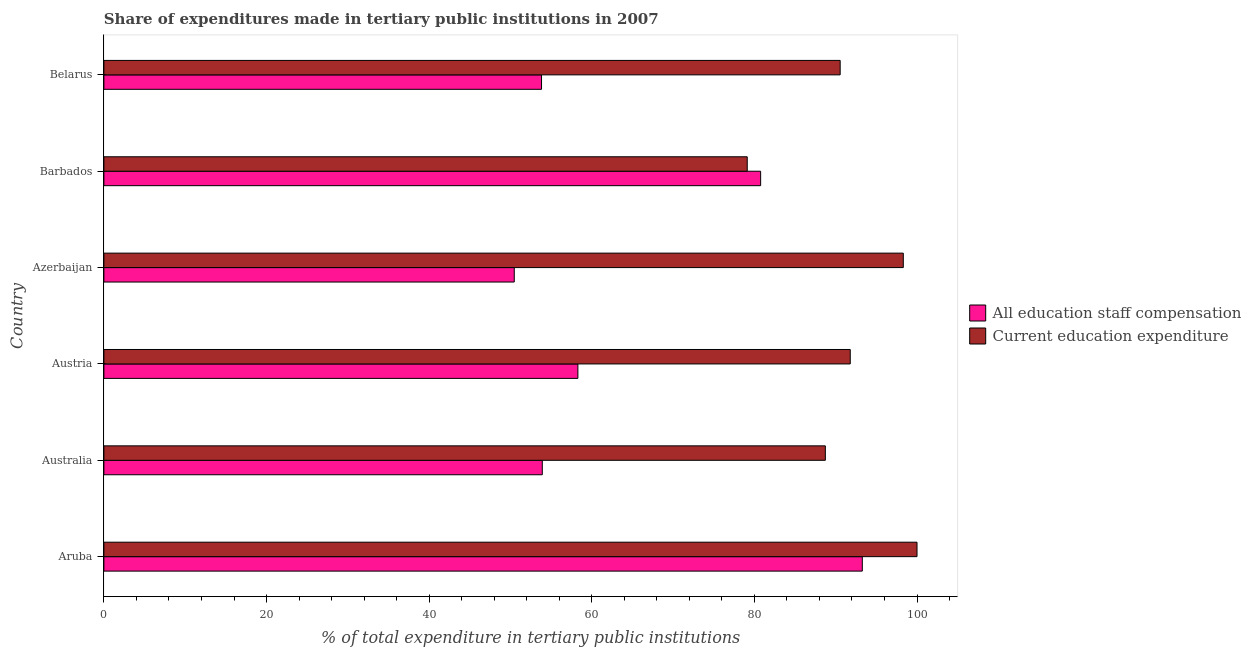Are the number of bars on each tick of the Y-axis equal?
Keep it short and to the point. Yes. How many bars are there on the 2nd tick from the bottom?
Give a very brief answer. 2. What is the label of the 2nd group of bars from the top?
Provide a succinct answer. Barbados. In how many cases, is the number of bars for a given country not equal to the number of legend labels?
Your response must be concise. 0. What is the expenditure in education in Australia?
Offer a terse response. 88.73. Across all countries, what is the maximum expenditure in staff compensation?
Give a very brief answer. 93.27. Across all countries, what is the minimum expenditure in education?
Your answer should be very brief. 79.12. In which country was the expenditure in education maximum?
Ensure brevity in your answer.  Aruba. In which country was the expenditure in staff compensation minimum?
Ensure brevity in your answer.  Azerbaijan. What is the total expenditure in education in the graph?
Offer a very short reply. 548.49. What is the difference between the expenditure in staff compensation in Aruba and that in Australia?
Your answer should be compact. 39.36. What is the difference between the expenditure in education in Barbados and the expenditure in staff compensation in Aruba?
Your response must be concise. -14.15. What is the average expenditure in staff compensation per country?
Make the answer very short. 65.09. What is the difference between the expenditure in education and expenditure in staff compensation in Barbados?
Make the answer very short. -1.65. What is the ratio of the expenditure in staff compensation in Azerbaijan to that in Belarus?
Provide a short and direct response. 0.94. Is the expenditure in education in Azerbaijan less than that in Belarus?
Provide a short and direct response. No. Is the difference between the expenditure in staff compensation in Australia and Barbados greater than the difference between the expenditure in education in Australia and Barbados?
Offer a very short reply. No. What is the difference between the highest and the second highest expenditure in staff compensation?
Keep it short and to the point. 12.5. What is the difference between the highest and the lowest expenditure in staff compensation?
Make the answer very short. 42.8. In how many countries, is the expenditure in staff compensation greater than the average expenditure in staff compensation taken over all countries?
Your response must be concise. 2. Is the sum of the expenditure in education in Aruba and Azerbaijan greater than the maximum expenditure in staff compensation across all countries?
Keep it short and to the point. Yes. What does the 2nd bar from the top in Azerbaijan represents?
Ensure brevity in your answer.  All education staff compensation. What does the 2nd bar from the bottom in Aruba represents?
Ensure brevity in your answer.  Current education expenditure. What is the difference between two consecutive major ticks on the X-axis?
Your response must be concise. 20. Does the graph contain grids?
Provide a succinct answer. No. Where does the legend appear in the graph?
Offer a very short reply. Center right. How are the legend labels stacked?
Provide a short and direct response. Vertical. What is the title of the graph?
Offer a very short reply. Share of expenditures made in tertiary public institutions in 2007. What is the label or title of the X-axis?
Your answer should be compact. % of total expenditure in tertiary public institutions. What is the % of total expenditure in tertiary public institutions in All education staff compensation in Aruba?
Keep it short and to the point. 93.27. What is the % of total expenditure in tertiary public institutions of Current education expenditure in Aruba?
Keep it short and to the point. 100. What is the % of total expenditure in tertiary public institutions of All education staff compensation in Australia?
Your answer should be compact. 53.91. What is the % of total expenditure in tertiary public institutions of Current education expenditure in Australia?
Offer a very short reply. 88.73. What is the % of total expenditure in tertiary public institutions of All education staff compensation in Austria?
Keep it short and to the point. 58.29. What is the % of total expenditure in tertiary public institutions of Current education expenditure in Austria?
Make the answer very short. 91.79. What is the % of total expenditure in tertiary public institutions in All education staff compensation in Azerbaijan?
Offer a terse response. 50.47. What is the % of total expenditure in tertiary public institutions of Current education expenditure in Azerbaijan?
Offer a very short reply. 98.31. What is the % of total expenditure in tertiary public institutions in All education staff compensation in Barbados?
Your answer should be very brief. 80.77. What is the % of total expenditure in tertiary public institutions of Current education expenditure in Barbados?
Your response must be concise. 79.12. What is the % of total expenditure in tertiary public institutions of All education staff compensation in Belarus?
Your response must be concise. 53.82. What is the % of total expenditure in tertiary public institutions of Current education expenditure in Belarus?
Your response must be concise. 90.55. Across all countries, what is the maximum % of total expenditure in tertiary public institutions of All education staff compensation?
Your answer should be very brief. 93.27. Across all countries, what is the maximum % of total expenditure in tertiary public institutions in Current education expenditure?
Ensure brevity in your answer.  100. Across all countries, what is the minimum % of total expenditure in tertiary public institutions of All education staff compensation?
Your answer should be compact. 50.47. Across all countries, what is the minimum % of total expenditure in tertiary public institutions in Current education expenditure?
Your answer should be compact. 79.12. What is the total % of total expenditure in tertiary public institutions of All education staff compensation in the graph?
Give a very brief answer. 390.54. What is the total % of total expenditure in tertiary public institutions in Current education expenditure in the graph?
Ensure brevity in your answer.  548.49. What is the difference between the % of total expenditure in tertiary public institutions of All education staff compensation in Aruba and that in Australia?
Ensure brevity in your answer.  39.36. What is the difference between the % of total expenditure in tertiary public institutions of Current education expenditure in Aruba and that in Australia?
Offer a very short reply. 11.27. What is the difference between the % of total expenditure in tertiary public institutions of All education staff compensation in Aruba and that in Austria?
Your answer should be compact. 34.98. What is the difference between the % of total expenditure in tertiary public institutions of Current education expenditure in Aruba and that in Austria?
Your response must be concise. 8.21. What is the difference between the % of total expenditure in tertiary public institutions of All education staff compensation in Aruba and that in Azerbaijan?
Make the answer very short. 42.8. What is the difference between the % of total expenditure in tertiary public institutions in Current education expenditure in Aruba and that in Azerbaijan?
Offer a terse response. 1.69. What is the difference between the % of total expenditure in tertiary public institutions of All education staff compensation in Aruba and that in Barbados?
Ensure brevity in your answer.  12.5. What is the difference between the % of total expenditure in tertiary public institutions in Current education expenditure in Aruba and that in Barbados?
Make the answer very short. 20.88. What is the difference between the % of total expenditure in tertiary public institutions of All education staff compensation in Aruba and that in Belarus?
Keep it short and to the point. 39.45. What is the difference between the % of total expenditure in tertiary public institutions of Current education expenditure in Aruba and that in Belarus?
Offer a terse response. 9.45. What is the difference between the % of total expenditure in tertiary public institutions in All education staff compensation in Australia and that in Austria?
Offer a terse response. -4.38. What is the difference between the % of total expenditure in tertiary public institutions in Current education expenditure in Australia and that in Austria?
Provide a short and direct response. -3.06. What is the difference between the % of total expenditure in tertiary public institutions in All education staff compensation in Australia and that in Azerbaijan?
Ensure brevity in your answer.  3.45. What is the difference between the % of total expenditure in tertiary public institutions of Current education expenditure in Australia and that in Azerbaijan?
Provide a succinct answer. -9.59. What is the difference between the % of total expenditure in tertiary public institutions of All education staff compensation in Australia and that in Barbados?
Give a very brief answer. -26.85. What is the difference between the % of total expenditure in tertiary public institutions of Current education expenditure in Australia and that in Barbados?
Your answer should be compact. 9.61. What is the difference between the % of total expenditure in tertiary public institutions of All education staff compensation in Australia and that in Belarus?
Provide a succinct answer. 0.09. What is the difference between the % of total expenditure in tertiary public institutions of Current education expenditure in Australia and that in Belarus?
Your response must be concise. -1.82. What is the difference between the % of total expenditure in tertiary public institutions in All education staff compensation in Austria and that in Azerbaijan?
Give a very brief answer. 7.82. What is the difference between the % of total expenditure in tertiary public institutions in Current education expenditure in Austria and that in Azerbaijan?
Offer a very short reply. -6.53. What is the difference between the % of total expenditure in tertiary public institutions in All education staff compensation in Austria and that in Barbados?
Your answer should be compact. -22.47. What is the difference between the % of total expenditure in tertiary public institutions of Current education expenditure in Austria and that in Barbados?
Your response must be concise. 12.67. What is the difference between the % of total expenditure in tertiary public institutions of All education staff compensation in Austria and that in Belarus?
Give a very brief answer. 4.47. What is the difference between the % of total expenditure in tertiary public institutions of Current education expenditure in Austria and that in Belarus?
Keep it short and to the point. 1.24. What is the difference between the % of total expenditure in tertiary public institutions of All education staff compensation in Azerbaijan and that in Barbados?
Offer a very short reply. -30.3. What is the difference between the % of total expenditure in tertiary public institutions in Current education expenditure in Azerbaijan and that in Barbados?
Ensure brevity in your answer.  19.19. What is the difference between the % of total expenditure in tertiary public institutions in All education staff compensation in Azerbaijan and that in Belarus?
Your answer should be very brief. -3.35. What is the difference between the % of total expenditure in tertiary public institutions in Current education expenditure in Azerbaijan and that in Belarus?
Provide a short and direct response. 7.76. What is the difference between the % of total expenditure in tertiary public institutions in All education staff compensation in Barbados and that in Belarus?
Give a very brief answer. 26.95. What is the difference between the % of total expenditure in tertiary public institutions of Current education expenditure in Barbados and that in Belarus?
Offer a very short reply. -11.43. What is the difference between the % of total expenditure in tertiary public institutions in All education staff compensation in Aruba and the % of total expenditure in tertiary public institutions in Current education expenditure in Australia?
Offer a terse response. 4.55. What is the difference between the % of total expenditure in tertiary public institutions in All education staff compensation in Aruba and the % of total expenditure in tertiary public institutions in Current education expenditure in Austria?
Offer a very short reply. 1.48. What is the difference between the % of total expenditure in tertiary public institutions of All education staff compensation in Aruba and the % of total expenditure in tertiary public institutions of Current education expenditure in Azerbaijan?
Ensure brevity in your answer.  -5.04. What is the difference between the % of total expenditure in tertiary public institutions of All education staff compensation in Aruba and the % of total expenditure in tertiary public institutions of Current education expenditure in Barbados?
Your answer should be compact. 14.15. What is the difference between the % of total expenditure in tertiary public institutions of All education staff compensation in Aruba and the % of total expenditure in tertiary public institutions of Current education expenditure in Belarus?
Offer a very short reply. 2.72. What is the difference between the % of total expenditure in tertiary public institutions of All education staff compensation in Australia and the % of total expenditure in tertiary public institutions of Current education expenditure in Austria?
Give a very brief answer. -37.87. What is the difference between the % of total expenditure in tertiary public institutions of All education staff compensation in Australia and the % of total expenditure in tertiary public institutions of Current education expenditure in Azerbaijan?
Your answer should be very brief. -44.4. What is the difference between the % of total expenditure in tertiary public institutions of All education staff compensation in Australia and the % of total expenditure in tertiary public institutions of Current education expenditure in Barbados?
Your answer should be very brief. -25.21. What is the difference between the % of total expenditure in tertiary public institutions of All education staff compensation in Australia and the % of total expenditure in tertiary public institutions of Current education expenditure in Belarus?
Provide a short and direct response. -36.63. What is the difference between the % of total expenditure in tertiary public institutions of All education staff compensation in Austria and the % of total expenditure in tertiary public institutions of Current education expenditure in Azerbaijan?
Offer a very short reply. -40.02. What is the difference between the % of total expenditure in tertiary public institutions in All education staff compensation in Austria and the % of total expenditure in tertiary public institutions in Current education expenditure in Barbados?
Provide a short and direct response. -20.83. What is the difference between the % of total expenditure in tertiary public institutions of All education staff compensation in Austria and the % of total expenditure in tertiary public institutions of Current education expenditure in Belarus?
Give a very brief answer. -32.25. What is the difference between the % of total expenditure in tertiary public institutions of All education staff compensation in Azerbaijan and the % of total expenditure in tertiary public institutions of Current education expenditure in Barbados?
Your response must be concise. -28.65. What is the difference between the % of total expenditure in tertiary public institutions of All education staff compensation in Azerbaijan and the % of total expenditure in tertiary public institutions of Current education expenditure in Belarus?
Give a very brief answer. -40.08. What is the difference between the % of total expenditure in tertiary public institutions of All education staff compensation in Barbados and the % of total expenditure in tertiary public institutions of Current education expenditure in Belarus?
Your answer should be very brief. -9.78. What is the average % of total expenditure in tertiary public institutions of All education staff compensation per country?
Provide a succinct answer. 65.09. What is the average % of total expenditure in tertiary public institutions in Current education expenditure per country?
Your answer should be compact. 91.42. What is the difference between the % of total expenditure in tertiary public institutions in All education staff compensation and % of total expenditure in tertiary public institutions in Current education expenditure in Aruba?
Keep it short and to the point. -6.73. What is the difference between the % of total expenditure in tertiary public institutions of All education staff compensation and % of total expenditure in tertiary public institutions of Current education expenditure in Australia?
Keep it short and to the point. -34.81. What is the difference between the % of total expenditure in tertiary public institutions of All education staff compensation and % of total expenditure in tertiary public institutions of Current education expenditure in Austria?
Provide a short and direct response. -33.49. What is the difference between the % of total expenditure in tertiary public institutions in All education staff compensation and % of total expenditure in tertiary public institutions in Current education expenditure in Azerbaijan?
Your response must be concise. -47.84. What is the difference between the % of total expenditure in tertiary public institutions of All education staff compensation and % of total expenditure in tertiary public institutions of Current education expenditure in Barbados?
Your answer should be very brief. 1.65. What is the difference between the % of total expenditure in tertiary public institutions in All education staff compensation and % of total expenditure in tertiary public institutions in Current education expenditure in Belarus?
Offer a terse response. -36.73. What is the ratio of the % of total expenditure in tertiary public institutions in All education staff compensation in Aruba to that in Australia?
Offer a terse response. 1.73. What is the ratio of the % of total expenditure in tertiary public institutions in Current education expenditure in Aruba to that in Australia?
Ensure brevity in your answer.  1.13. What is the ratio of the % of total expenditure in tertiary public institutions in All education staff compensation in Aruba to that in Austria?
Give a very brief answer. 1.6. What is the ratio of the % of total expenditure in tertiary public institutions of Current education expenditure in Aruba to that in Austria?
Your answer should be very brief. 1.09. What is the ratio of the % of total expenditure in tertiary public institutions in All education staff compensation in Aruba to that in Azerbaijan?
Your response must be concise. 1.85. What is the ratio of the % of total expenditure in tertiary public institutions in Current education expenditure in Aruba to that in Azerbaijan?
Provide a succinct answer. 1.02. What is the ratio of the % of total expenditure in tertiary public institutions of All education staff compensation in Aruba to that in Barbados?
Your response must be concise. 1.15. What is the ratio of the % of total expenditure in tertiary public institutions in Current education expenditure in Aruba to that in Barbados?
Your response must be concise. 1.26. What is the ratio of the % of total expenditure in tertiary public institutions of All education staff compensation in Aruba to that in Belarus?
Keep it short and to the point. 1.73. What is the ratio of the % of total expenditure in tertiary public institutions in Current education expenditure in Aruba to that in Belarus?
Ensure brevity in your answer.  1.1. What is the ratio of the % of total expenditure in tertiary public institutions of All education staff compensation in Australia to that in Austria?
Provide a short and direct response. 0.92. What is the ratio of the % of total expenditure in tertiary public institutions in Current education expenditure in Australia to that in Austria?
Offer a terse response. 0.97. What is the ratio of the % of total expenditure in tertiary public institutions in All education staff compensation in Australia to that in Azerbaijan?
Provide a succinct answer. 1.07. What is the ratio of the % of total expenditure in tertiary public institutions of Current education expenditure in Australia to that in Azerbaijan?
Give a very brief answer. 0.9. What is the ratio of the % of total expenditure in tertiary public institutions in All education staff compensation in Australia to that in Barbados?
Ensure brevity in your answer.  0.67. What is the ratio of the % of total expenditure in tertiary public institutions in Current education expenditure in Australia to that in Barbados?
Give a very brief answer. 1.12. What is the ratio of the % of total expenditure in tertiary public institutions of Current education expenditure in Australia to that in Belarus?
Provide a short and direct response. 0.98. What is the ratio of the % of total expenditure in tertiary public institutions of All education staff compensation in Austria to that in Azerbaijan?
Provide a short and direct response. 1.16. What is the ratio of the % of total expenditure in tertiary public institutions in Current education expenditure in Austria to that in Azerbaijan?
Provide a succinct answer. 0.93. What is the ratio of the % of total expenditure in tertiary public institutions of All education staff compensation in Austria to that in Barbados?
Your answer should be compact. 0.72. What is the ratio of the % of total expenditure in tertiary public institutions of Current education expenditure in Austria to that in Barbados?
Your answer should be compact. 1.16. What is the ratio of the % of total expenditure in tertiary public institutions of All education staff compensation in Austria to that in Belarus?
Offer a very short reply. 1.08. What is the ratio of the % of total expenditure in tertiary public institutions in Current education expenditure in Austria to that in Belarus?
Offer a terse response. 1.01. What is the ratio of the % of total expenditure in tertiary public institutions in All education staff compensation in Azerbaijan to that in Barbados?
Keep it short and to the point. 0.62. What is the ratio of the % of total expenditure in tertiary public institutions in Current education expenditure in Azerbaijan to that in Barbados?
Keep it short and to the point. 1.24. What is the ratio of the % of total expenditure in tertiary public institutions of All education staff compensation in Azerbaijan to that in Belarus?
Give a very brief answer. 0.94. What is the ratio of the % of total expenditure in tertiary public institutions in Current education expenditure in Azerbaijan to that in Belarus?
Give a very brief answer. 1.09. What is the ratio of the % of total expenditure in tertiary public institutions of All education staff compensation in Barbados to that in Belarus?
Your answer should be very brief. 1.5. What is the ratio of the % of total expenditure in tertiary public institutions in Current education expenditure in Barbados to that in Belarus?
Offer a very short reply. 0.87. What is the difference between the highest and the second highest % of total expenditure in tertiary public institutions in All education staff compensation?
Keep it short and to the point. 12.5. What is the difference between the highest and the second highest % of total expenditure in tertiary public institutions of Current education expenditure?
Keep it short and to the point. 1.69. What is the difference between the highest and the lowest % of total expenditure in tertiary public institutions of All education staff compensation?
Give a very brief answer. 42.8. What is the difference between the highest and the lowest % of total expenditure in tertiary public institutions in Current education expenditure?
Make the answer very short. 20.88. 